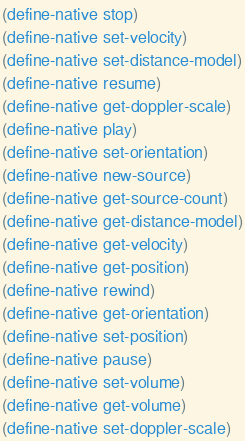Convert code to text. <code><loc_0><loc_0><loc_500><loc_500><_Lisp_>(define-native stop)
(define-native set-velocity)
(define-native set-distance-model)
(define-native resume)
(define-native get-doppler-scale)
(define-native play)
(define-native set-orientation)
(define-native new-source)
(define-native get-source-count)
(define-native get-distance-model)
(define-native get-velocity)
(define-native get-position)
(define-native rewind)
(define-native get-orientation)
(define-native set-position)
(define-native pause)
(define-native set-volume)
(define-native get-volume)
(define-native set-doppler-scale)
</code> 